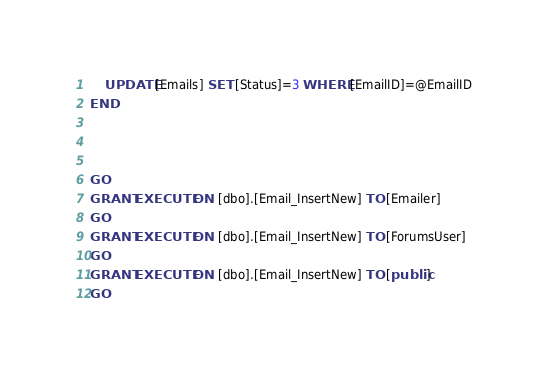Convert code to text. <code><loc_0><loc_0><loc_500><loc_500><_SQL_>	UPDATE [Emails] SET [Status]=3 WHERE [EmailID]=@EmailID
END



GO
GRANT EXECUTE ON  [dbo].[Email_InsertNew] TO [Emailer]
GO
GRANT EXECUTE ON  [dbo].[Email_InsertNew] TO [ForumsUser]
GO
GRANT EXECUTE ON  [dbo].[Email_InsertNew] TO [public]
GO
</code> 